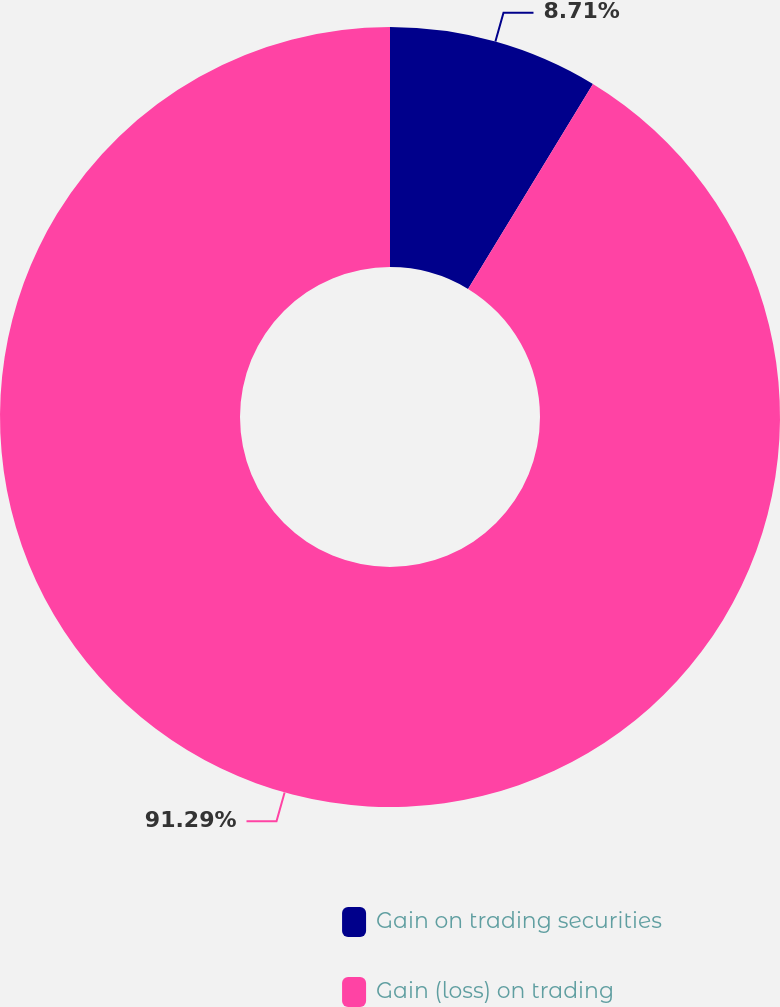Convert chart. <chart><loc_0><loc_0><loc_500><loc_500><pie_chart><fcel>Gain on trading securities<fcel>Gain (loss) on trading<nl><fcel>8.71%<fcel>91.29%<nl></chart> 